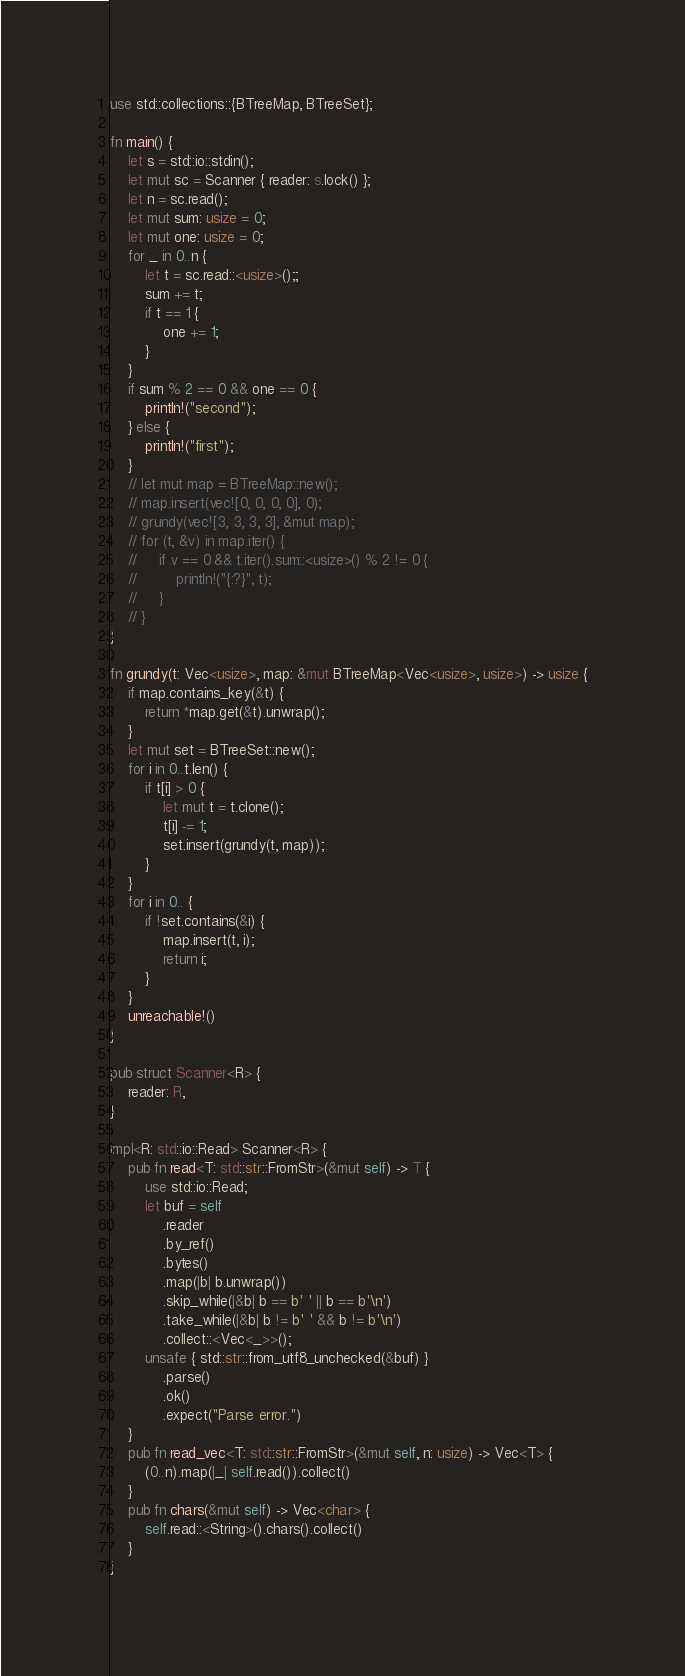<code> <loc_0><loc_0><loc_500><loc_500><_Rust_>use std::collections::{BTreeMap, BTreeSet};

fn main() {
    let s = std::io::stdin();
    let mut sc = Scanner { reader: s.lock() };
    let n = sc.read();
    let mut sum: usize = 0;
    let mut one: usize = 0;
    for _ in 0..n {
        let t = sc.read::<usize>();;
        sum += t;
        if t == 1 {
            one += 1;
        }
    }
    if sum % 2 == 0 && one == 0 {
        println!("second");
    } else {
        println!("first");
    }
    // let mut map = BTreeMap::new();
    // map.insert(vec![0, 0, 0, 0], 0);
    // grundy(vec![3, 3, 3, 3], &mut map);
    // for (t, &v) in map.iter() {
    //     if v == 0 && t.iter().sum::<usize>() % 2 != 0 {
    //         println!("{:?}", t);
    //     }
    // }
}

fn grundy(t: Vec<usize>, map: &mut BTreeMap<Vec<usize>, usize>) -> usize {
    if map.contains_key(&t) {
        return *map.get(&t).unwrap();
    }
    let mut set = BTreeSet::new();
    for i in 0..t.len() {
        if t[i] > 0 {
            let mut t = t.clone();
            t[i] -= 1;
            set.insert(grundy(t, map));
        }
    }
    for i in 0.. {
        if !set.contains(&i) {
            map.insert(t, i);
            return i;
        }
    }
    unreachable!()
}

pub struct Scanner<R> {
    reader: R,
}

impl<R: std::io::Read> Scanner<R> {
    pub fn read<T: std::str::FromStr>(&mut self) -> T {
        use std::io::Read;
        let buf = self
            .reader
            .by_ref()
            .bytes()
            .map(|b| b.unwrap())
            .skip_while(|&b| b == b' ' || b == b'\n')
            .take_while(|&b| b != b' ' && b != b'\n')
            .collect::<Vec<_>>();
        unsafe { std::str::from_utf8_unchecked(&buf) }
            .parse()
            .ok()
            .expect("Parse error.")
    }
    pub fn read_vec<T: std::str::FromStr>(&mut self, n: usize) -> Vec<T> {
        (0..n).map(|_| self.read()).collect()
    }
    pub fn chars(&mut self) -> Vec<char> {
        self.read::<String>().chars().collect()
    }
}
</code> 